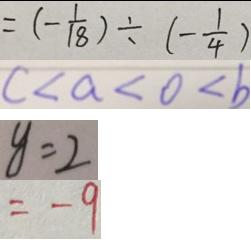<formula> <loc_0><loc_0><loc_500><loc_500>= ( - \frac { 1 } { 1 8 } ) \div ( - \frac { 1 } { 4 } ) 
 c < a < 0 < b 
 y = 2 
 = - 9</formula> 